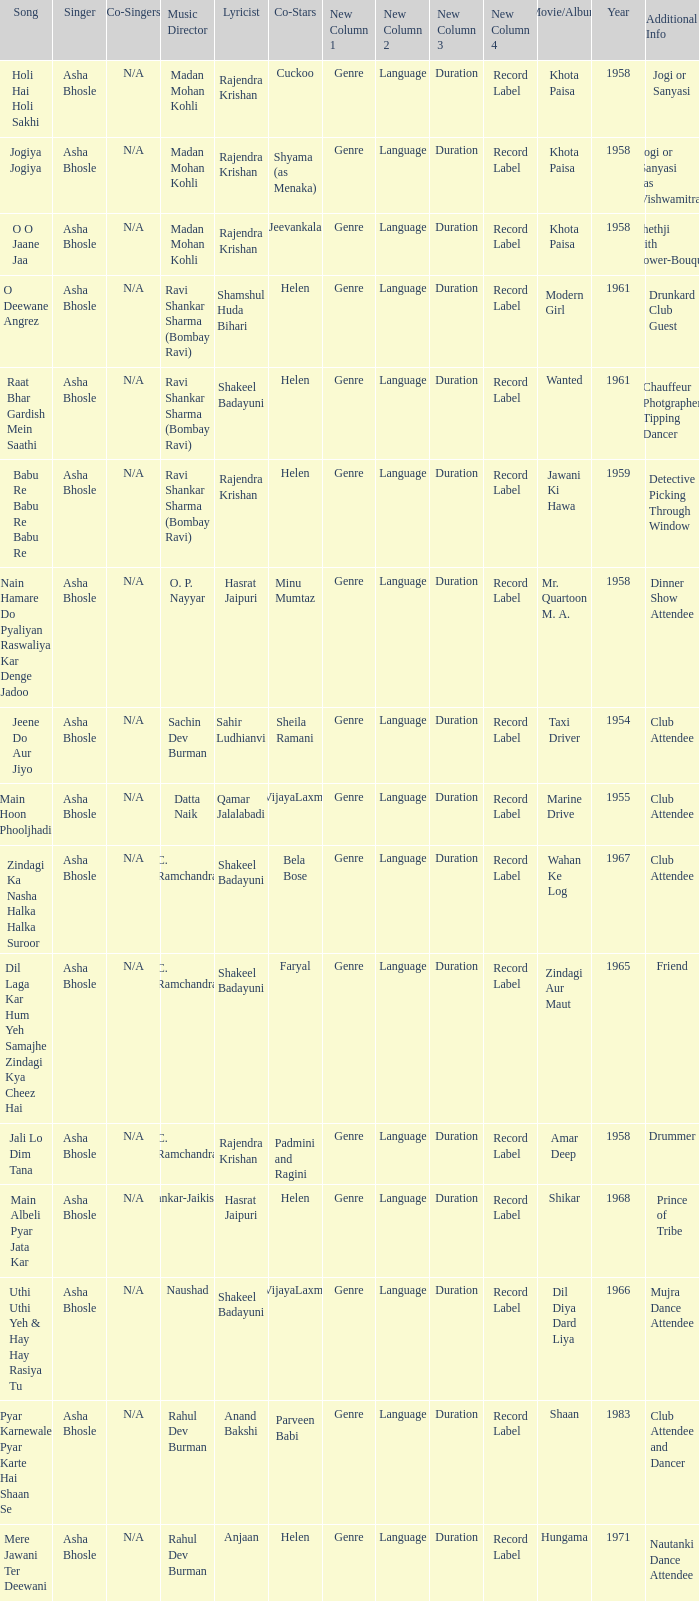Can you parse all the data within this table? {'header': ['Song', 'Singer', 'Co-Singers', 'Music Director', 'Lyricist', 'Co-Stars', 'New Column 1', 'New Column 2', 'New Column 3', 'New Column 4', 'Movie/Album', 'Year', 'Additional Info'], 'rows': [['Holi Hai Holi Sakhi', 'Asha Bhosle', 'N/A', 'Madan Mohan Kohli', 'Rajendra Krishan', 'Cuckoo', 'Genre', 'Language', 'Duration', 'Record Label', 'Khota Paisa', '1958', 'Jogi or Sanyasi'], ['Jogiya Jogiya', 'Asha Bhosle', 'N/A', 'Madan Mohan Kohli', 'Rajendra Krishan', 'Shyama (as Menaka)', 'Genre', 'Language', 'Duration', 'Record Label', 'Khota Paisa', '1958', 'Jogi or Sanyasi (as Vishwamitra)'], ['O O Jaane Jaa', 'Asha Bhosle', 'N/A', 'Madan Mohan Kohli', 'Rajendra Krishan', 'Jeevankala', 'Genre', 'Language', 'Duration', 'Record Label', 'Khota Paisa', '1958', 'Shethji with flower-Bouque'], ['O Deewane Angrez', 'Asha Bhosle', 'N/A', 'Ravi Shankar Sharma (Bombay Ravi)', 'Shamshul Huda Bihari', 'Helen', 'Genre', 'Language', 'Duration', 'Record Label', 'Modern Girl', '1961', 'Drunkard Club Guest'], ['Raat Bhar Gardish Mein Saathi', 'Asha Bhosle', 'N/A', 'Ravi Shankar Sharma (Bombay Ravi)', 'Shakeel Badayuni', 'Helen', 'Genre', 'Language', 'Duration', 'Record Label', 'Wanted', '1961', 'Chauffeur Photgrapher Tipping Dancer'], ['Babu Re Babu Re Babu Re', 'Asha Bhosle', 'N/A', 'Ravi Shankar Sharma (Bombay Ravi)', 'Rajendra Krishan', 'Helen', 'Genre', 'Language', 'Duration', 'Record Label', 'Jawani Ki Hawa', '1959', 'Detective Picking Through Window'], ['Nain Hamare Do Pyaliyan Raswaliya Kar Denge Jadoo', 'Asha Bhosle', 'N/A', 'O. P. Nayyar', 'Hasrat Jaipuri', 'Minu Mumtaz', 'Genre', 'Language', 'Duration', 'Record Label', 'Mr. Quartoon M. A.', '1958', 'Dinner Show Attendee'], ['Jeene Do Aur Jiyo', 'Asha Bhosle', 'N/A', 'Sachin Dev Burman', 'Sahir Ludhianvi', 'Sheila Ramani', 'Genre', 'Language', 'Duration', 'Record Label', 'Taxi Driver', '1954', 'Club Attendee'], ['Main Hoon Phooljhadi', 'Asha Bhosle', 'N/A', 'Datta Naik', 'Qamar Jalalabadi', 'VijayaLaxmi', 'Genre', 'Language', 'Duration', 'Record Label', 'Marine Drive', '1955', 'Club Attendee'], ['Zindagi Ka Nasha Halka Halka Suroor', 'Asha Bhosle', 'N/A', 'C. Ramchandra', 'Shakeel Badayuni', 'Bela Bose', 'Genre', 'Language', 'Duration', 'Record Label', 'Wahan Ke Log', '1967', 'Club Attendee'], ['Dil Laga Kar Hum Yeh Samajhe Zindagi Kya Cheez Hai', 'Asha Bhosle', 'N/A', 'C. Ramchandra', 'Shakeel Badayuni', 'Faryal', 'Genre', 'Language', 'Duration', 'Record Label', 'Zindagi Aur Maut', '1965', 'Friend'], ['Jali Lo Dim Tana', 'Asha Bhosle', 'N/A', 'C. Ramchandra', 'Rajendra Krishan', 'Padmini and Ragini', 'Genre', 'Language', 'Duration', 'Record Label', 'Amar Deep', '1958', 'Drummer'], ['Main Albeli Pyar Jata Kar', 'Asha Bhosle', 'N/A', 'Shankar-Jaikishan', 'Hasrat Jaipuri', 'Helen', 'Genre', 'Language', 'Duration', 'Record Label', 'Shikar', '1968', 'Prince of Tribe'], ['Uthi Uthi Yeh & Hay Hay Rasiya Tu', 'Asha Bhosle', 'N/A', 'Naushad', 'Shakeel Badayuni', 'VijayaLaxmi', 'Genre', 'Language', 'Duration', 'Record Label', 'Dil Diya Dard Liya', '1966', 'Mujra Dance Attendee'], ['Pyar Karnewale Pyar Karte Hai Shaan Se', 'Asha Bhosle', 'N/A', 'Rahul Dev Burman', 'Anand Bakshi', 'Parveen Babi', 'Genre', 'Language', 'Duration', 'Record Label', 'Shaan', '1983', 'Club Attendee and Dancer'], ['Mere Jawani Ter Deewani', 'Asha Bhosle', 'N/A', 'Rahul Dev Burman', 'Anjaan', 'Helen', 'Genre', 'Language', 'Duration', 'Record Label', 'Hungama', '1971', 'Nautanki Dance Attendee']]} What movie did Bela Bose co-star in? Wahan Ke Log. 